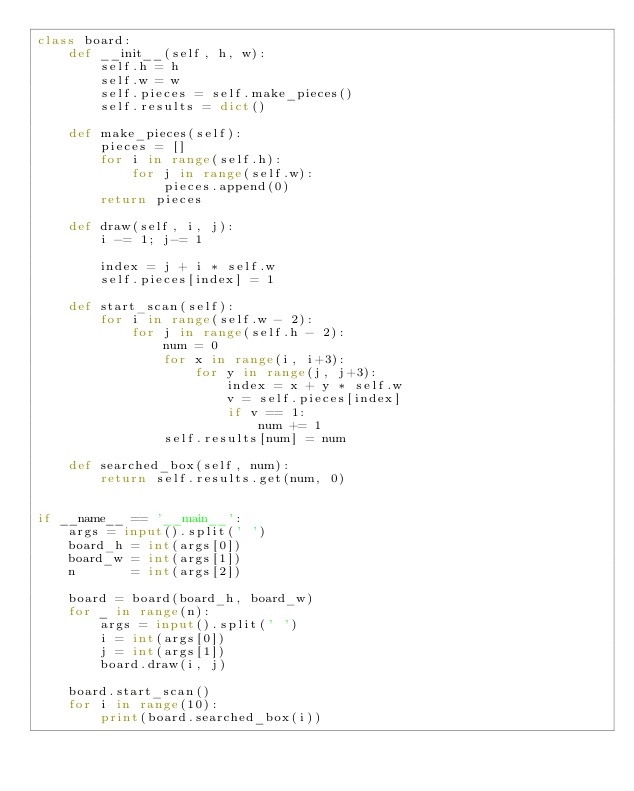Convert code to text. <code><loc_0><loc_0><loc_500><loc_500><_Python_>class board:
    def __init__(self, h, w):
        self.h = h
        self.w = w
        self.pieces = self.make_pieces()
        self.results = dict()

    def make_pieces(self):
        pieces = []
        for i in range(self.h):
            for j in range(self.w):
                pieces.append(0)
        return pieces

    def draw(self, i, j):
        i -= 1; j-= 1

        index = j + i * self.w
        self.pieces[index] = 1

    def start_scan(self):
        for i in range(self.w - 2):
            for j in range(self.h - 2):
                num = 0
                for x in range(i, i+3):
                    for y in range(j, j+3):
                        index = x + y * self.w
                        v = self.pieces[index]
                        if v == 1:
                            num += 1
                self.results[num] = num

    def searched_box(self, num):
        return self.results.get(num, 0)
        

if __name__ == '__main__':
    args = input().split(' ')
    board_h = int(args[0])
    board_w = int(args[1])
    n       = int(args[2])

    board = board(board_h, board_w)
    for _ in range(n):
        args = input().split(' ')
        i = int(args[0])
        j = int(args[1])
        board.draw(i, j)

    board.start_scan()
    for i in range(10):
        print(board.searched_box(i))
</code> 